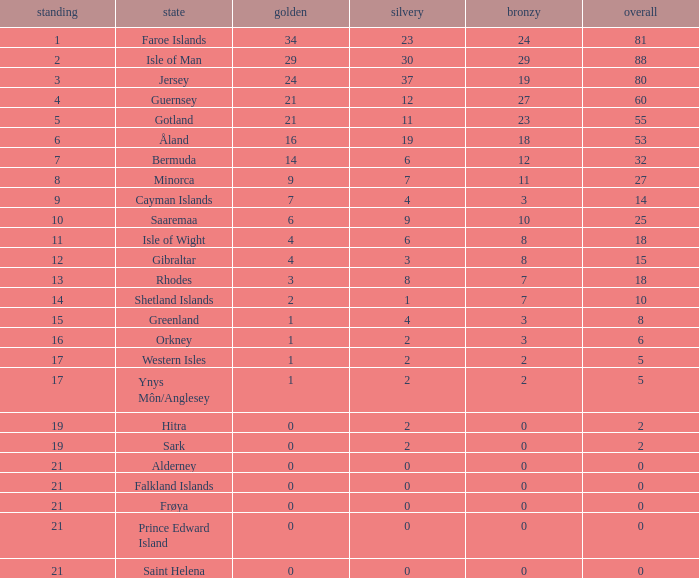How many Silver medals were won in total by all those with more than 3 bronze and exactly 16 gold? 19.0. 